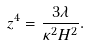Convert formula to latex. <formula><loc_0><loc_0><loc_500><loc_500>z ^ { 4 } = \frac { 3 \lambda } { \kappa ^ { 2 } H ^ { 2 } } .</formula> 